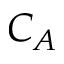Convert formula to latex. <formula><loc_0><loc_0><loc_500><loc_500>C _ { A }</formula> 